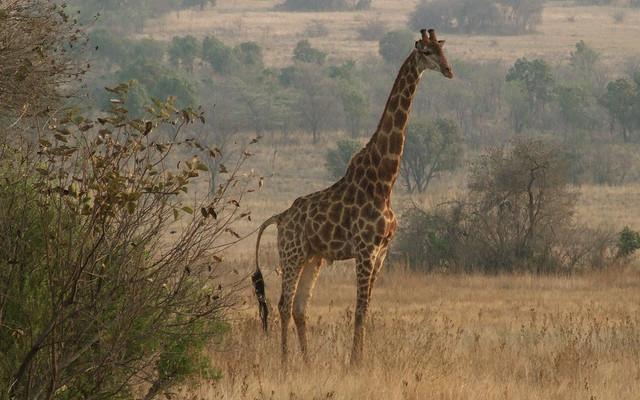How many giraffes are in the picture?
Write a very short answer. 1. What number of bushes are behind the giraffe?
Give a very brief answer. 3. Is the tree limb in the foreground an acacia?
Write a very short answer. No. What kind of animal is that?
Answer briefly. Giraffe. Does the giraffe have a long tail?
Give a very brief answer. Yes. Is the animal eating?
Keep it brief. No. Is this a zoo scene?
Keep it brief. No. Where are the giraffes?
Keep it brief. Field. Does the giraffe look tired?
Give a very brief answer. No. Is this picture in focus?
Keep it brief. Yes. Is this a baby animal?
Concise answer only. No. Is this at a zoo?
Answer briefly. No. Do these animals travel in herds?
Short answer required. Yes. Is the animal in densely brushed area?
Quick response, please. No. How many giraffes are walking around?
Concise answer only. 1. How many animals are in this scene?
Keep it brief. 1. How many giraffes are there?
Quick response, please. 1. How many giraffes?
Answer briefly. 1. Is this giraffe full grown?
Quick response, please. Yes. 